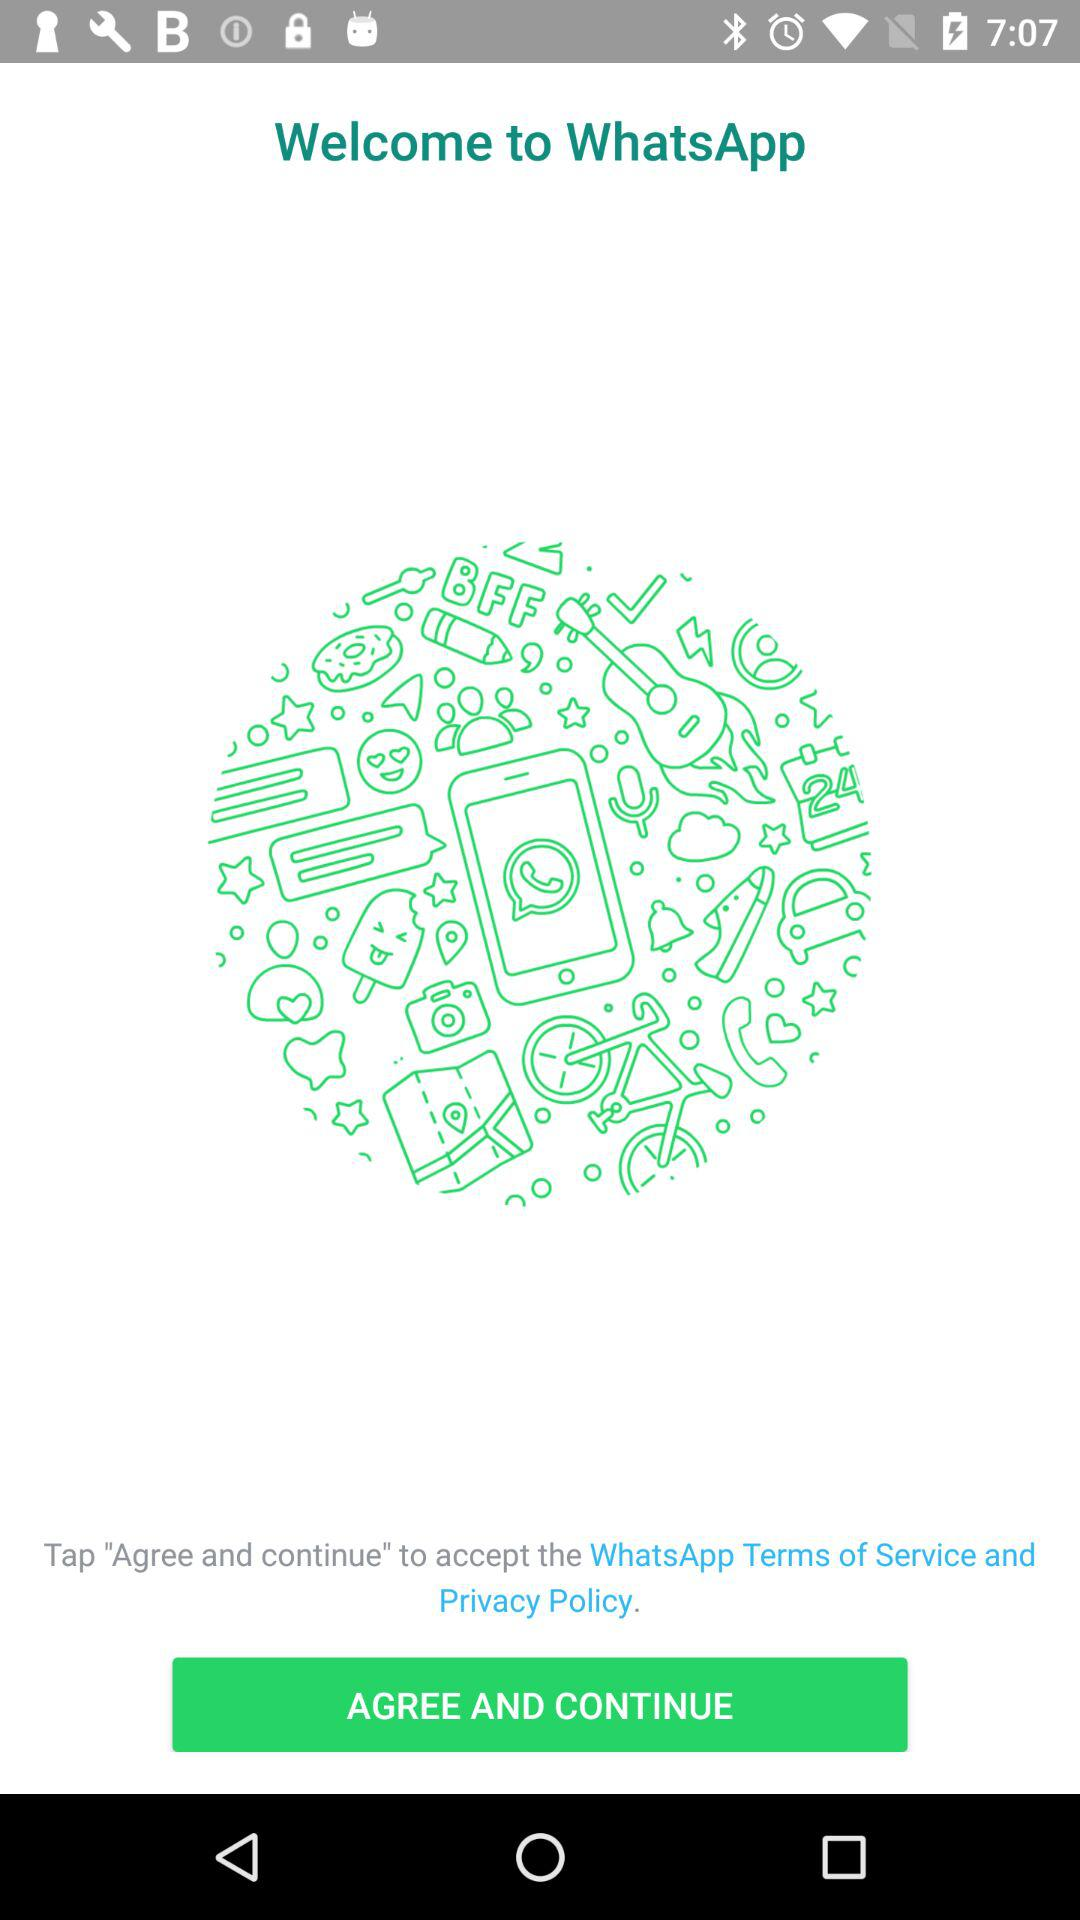What is the name of the application? The name of the application is "WhatsApp". 